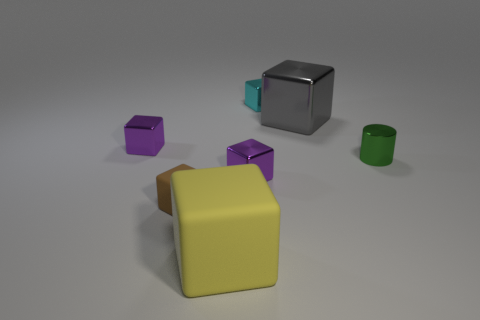There is a cyan cube; is it the same size as the metallic thing that is right of the large gray metal block?
Offer a very short reply. Yes. The cylinder that is the same size as the brown rubber object is what color?
Your answer should be compact. Green. How big is the gray metal object?
Keep it short and to the point. Large. Is the block that is on the left side of the brown thing made of the same material as the green thing?
Provide a succinct answer. Yes. Is the shape of the big rubber object the same as the large gray object?
Provide a succinct answer. Yes. The metallic object that is on the left side of the purple cube that is to the right of the thing to the left of the small matte block is what shape?
Provide a short and direct response. Cube. Does the small green thing that is to the right of the brown matte block have the same shape as the large object that is behind the yellow object?
Offer a very short reply. No. Is there a small blue block made of the same material as the cylinder?
Your answer should be very brief. No. What is the color of the large object that is in front of the purple shiny object left of the tiny purple metallic object in front of the small green object?
Your answer should be compact. Yellow. Do the purple cube to the right of the small brown thing and the tiny brown cube in front of the small cyan block have the same material?
Offer a very short reply. No. 